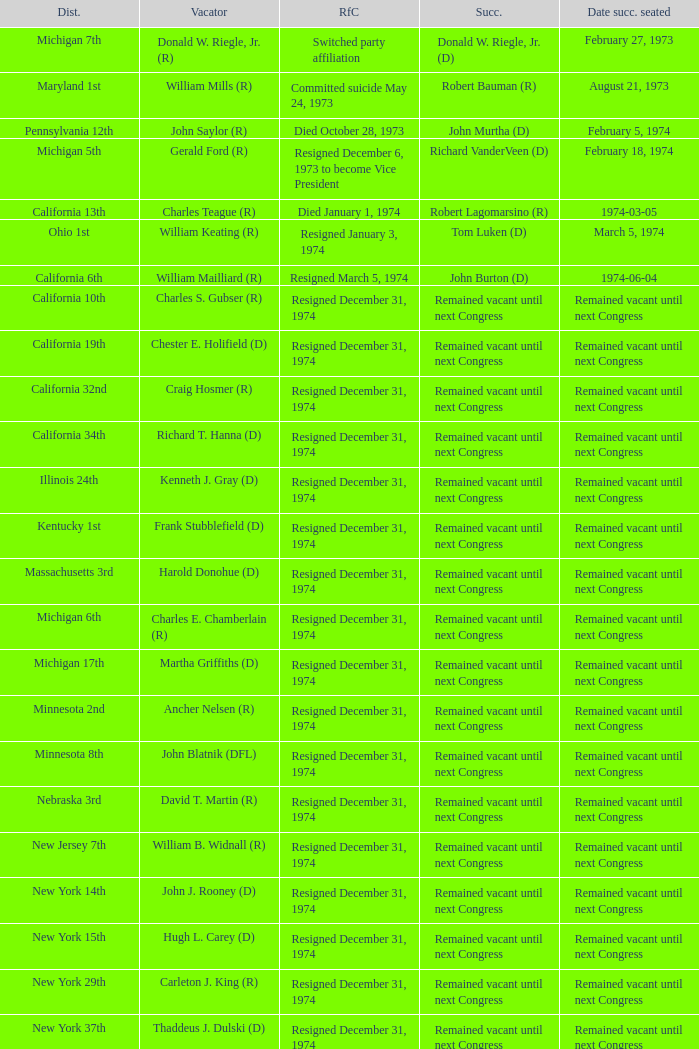Who was the successor when the vacator was chester e. holifield (d)? Remained vacant until next Congress. 